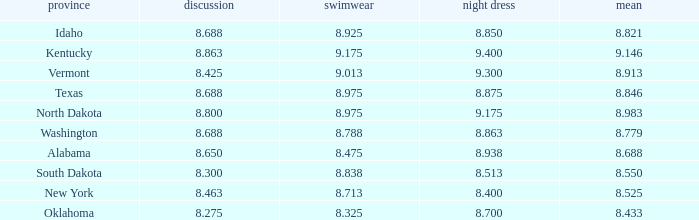What is the lowest average of the contestant with an interview of 8.275 and an evening gown bigger than 8.7? None. 